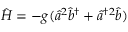Convert formula to latex. <formula><loc_0><loc_0><loc_500><loc_500>\begin{array} { r } { \hat { H } = - g ( \hat { a } ^ { 2 } \hat { b } ^ { \dagger } + \hat { a } ^ { \dagger 2 } \hat { b } ) } \end{array}</formula> 